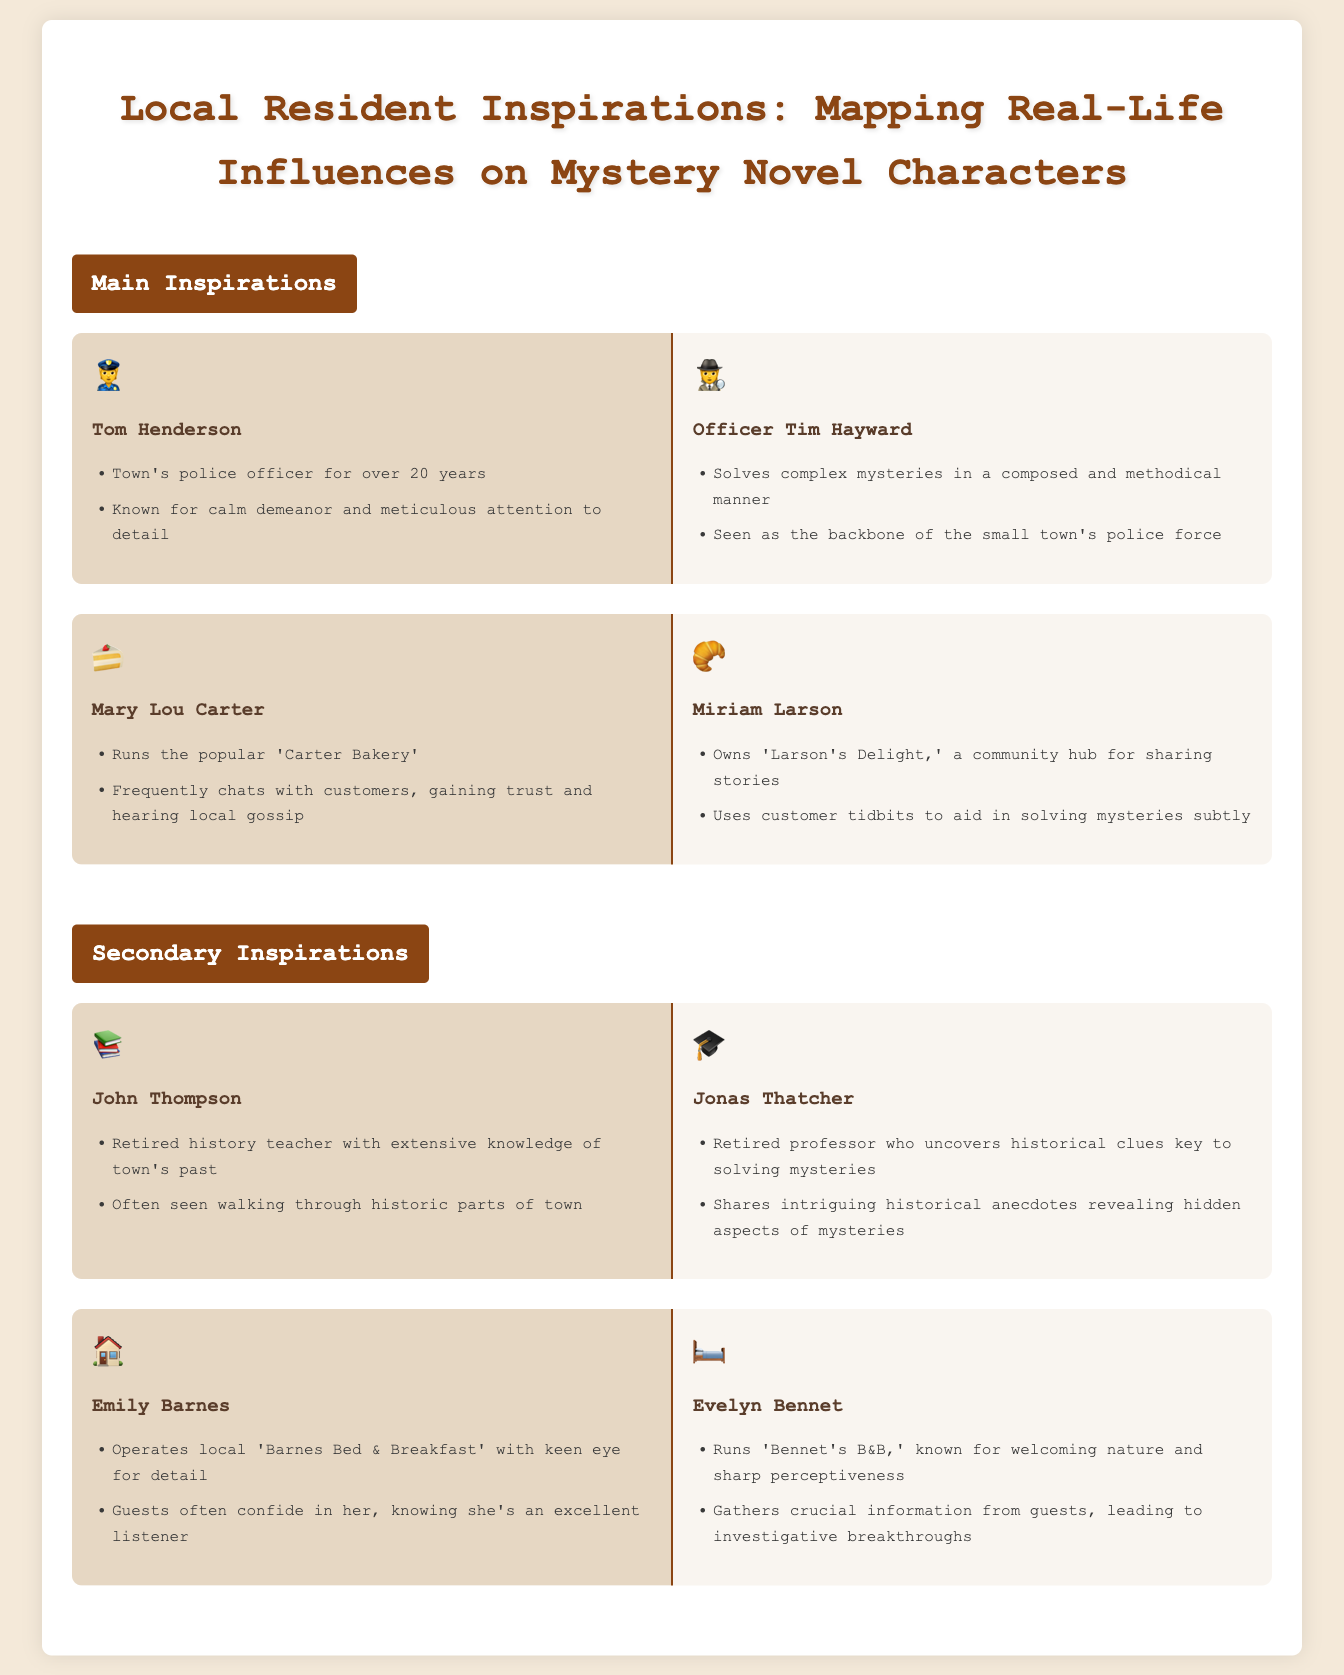what is the name of the town's police officer? The document identifies Tom Henderson as the town's police officer for over 20 years.
Answer: Tom Henderson what is the fictional name of the bakery owner? The fictional character inspired by Mary Lou Carter is named Miriam Larson who owns 'Larson's Delight.'
Answer: Miriam Larson how many years has Tom Henderson served as a police officer? The document states Tom Henderson has served for over 20 years.
Answer: over 20 years which character is known for gaining trust through conversation? The real-life inspiration Mary Lou Carter is noted for frequently chatting with customers.
Answer: Mary Lou Carter who is the retired history teacher mentioned? The document mentions John Thompson as the retired history teacher with extensive knowledge of the town's past.
Answer: John Thompson what is the name of the B&B run by the fictional character? The fictional character Evelyn Bennet runs 'Bennet's B&B.'
Answer: Bennet's B&B which character helps in solving mysteries by sharing historical anecdotes? The fictional character Jonas Thatcher uncovers historical clues key to solving mysteries through anecdotes.
Answer: Jonas Thatcher what type of business does Emily Barnes operate? The document states that Emily Barnes operates a bed & breakfast.
Answer: bed & breakfast which real-life resident influences a meticulous police character? The real-life inspiration Tom Henderson influences the fictional character Officer Tim Hayward, known for diligence.
Answer: Tom Henderson 